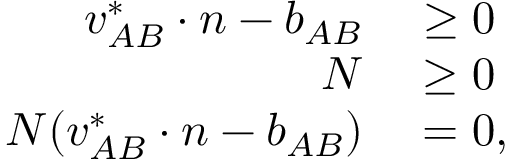<formula> <loc_0><loc_0><loc_500><loc_500>\begin{array} { r l } { { v } _ { A B } ^ { * } \cdot { n } - b _ { A B } } & \geq 0 } \\ { N } & \geq 0 } \\ { N ( { v } _ { A B } ^ { * } \cdot { n } - b _ { A B } ) } & = 0 , } \end{array}</formula> 